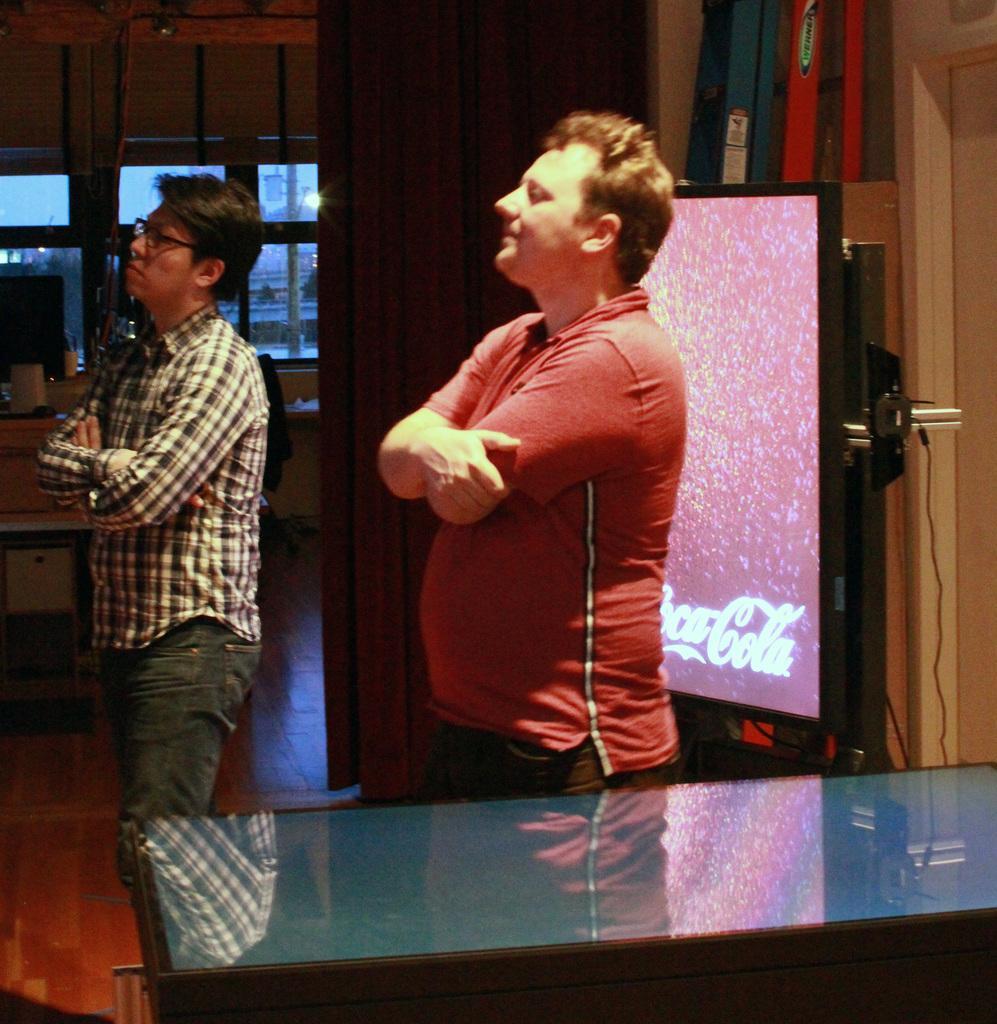How would you summarize this image in a sentence or two? In this image we can see two persons are standing beside there is a table. We can see display board and in the background there is a glass window. 